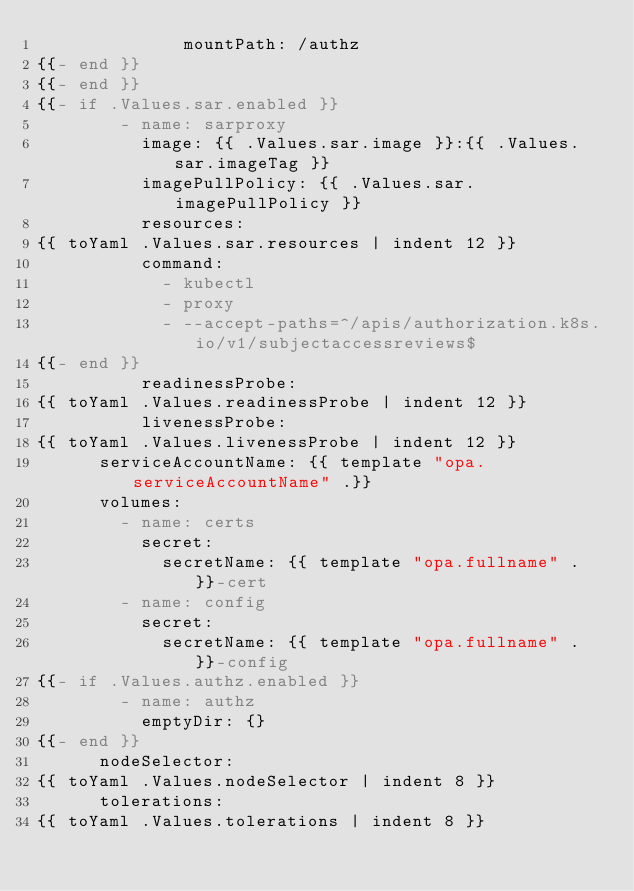Convert code to text. <code><loc_0><loc_0><loc_500><loc_500><_YAML_>              mountPath: /authz
{{- end }}
{{- end }}
{{- if .Values.sar.enabled }}
        - name: sarproxy
          image: {{ .Values.sar.image }}:{{ .Values.sar.imageTag }}
          imagePullPolicy: {{ .Values.sar.imagePullPolicy }}
          resources:
{{ toYaml .Values.sar.resources | indent 12 }}
          command:
            - kubectl
            - proxy
            - --accept-paths=^/apis/authorization.k8s.io/v1/subjectaccessreviews$
{{- end }}
          readinessProbe:
{{ toYaml .Values.readinessProbe | indent 12 }}
          livenessProbe:
{{ toYaml .Values.livenessProbe | indent 12 }}
      serviceAccountName: {{ template "opa.serviceAccountName" .}}
      volumes:
        - name: certs
          secret:
            secretName: {{ template "opa.fullname" . }}-cert
        - name: config
          secret:
            secretName: {{ template "opa.fullname" . }}-config
{{- if .Values.authz.enabled }}
        - name: authz
          emptyDir: {}
{{- end }}
      nodeSelector:
{{ toYaml .Values.nodeSelector | indent 8 }}
      tolerations:
{{ toYaml .Values.tolerations | indent 8 }}
</code> 